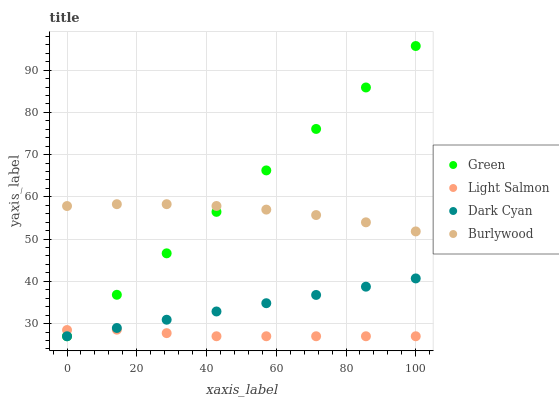Does Light Salmon have the minimum area under the curve?
Answer yes or no. Yes. Does Green have the maximum area under the curve?
Answer yes or no. Yes. Does Burlywood have the minimum area under the curve?
Answer yes or no. No. Does Burlywood have the maximum area under the curve?
Answer yes or no. No. Is Dark Cyan the smoothest?
Answer yes or no. Yes. Is Burlywood the roughest?
Answer yes or no. Yes. Is Light Salmon the smoothest?
Answer yes or no. No. Is Light Salmon the roughest?
Answer yes or no. No. Does Dark Cyan have the lowest value?
Answer yes or no. Yes. Does Burlywood have the lowest value?
Answer yes or no. No. Does Green have the highest value?
Answer yes or no. Yes. Does Burlywood have the highest value?
Answer yes or no. No. Is Dark Cyan less than Burlywood?
Answer yes or no. Yes. Is Burlywood greater than Dark Cyan?
Answer yes or no. Yes. Does Light Salmon intersect Dark Cyan?
Answer yes or no. Yes. Is Light Salmon less than Dark Cyan?
Answer yes or no. No. Is Light Salmon greater than Dark Cyan?
Answer yes or no. No. Does Dark Cyan intersect Burlywood?
Answer yes or no. No. 